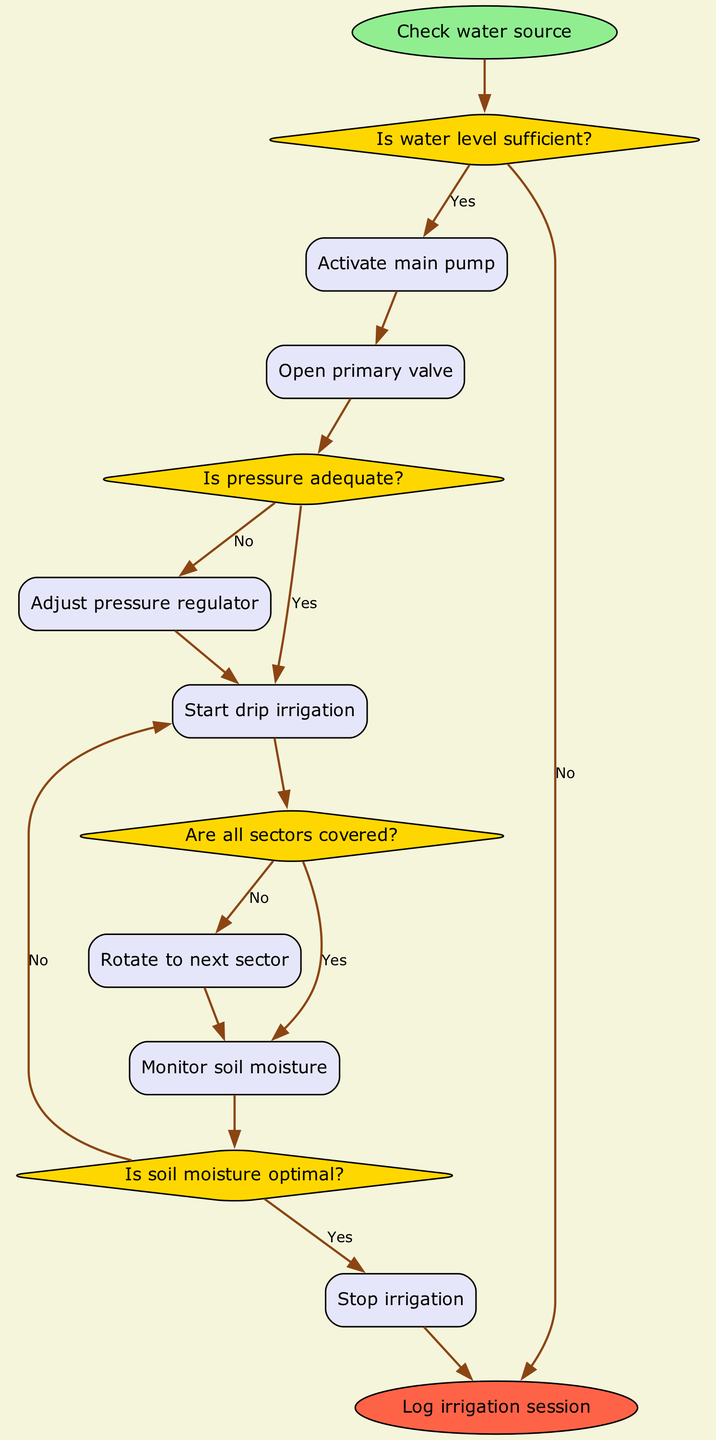What is the starting action in the irrigation system? The first action in the irrigation system is to check the water source, as indicated at the beginning of the flowchart.
Answer: Check water source What happens if the water level is insufficient? If the water level is insufficient, the flowchart indicates that the process ends without activating the main pump and stops the irrigation actions.
Answer: End How many decision points are there in the irrigation operation? The flowchart illustrates four decision points where conditions are checked, specifically regarding water level, pressure, sector coverage, and soil moisture.
Answer: Four What is the action taken if the pressure is inadequate? If the pressure is inadequate, the next action taken is to adjust the pressure regulator, as shown proceeding from the corresponding decision node.
Answer: Adjust pressure regulator What action is taken once all sectors are covered? The flowchart indicates that once all sectors are covered, the next step is to monitor soil moisture, moving onward from that decision.
Answer: Monitor soil moisture How do you know when to stop the irrigation process? The irrigation process is stopped when the soil moisture is found to be optimal. This is indicated by the decision point that checks soil moisture levels before stopping.
Answer: Stop irrigation What leads to the action of starting drip irrigation? The flowchart shows that starting drip irrigation occurs only if the pressure is adequate, establishing a direct correlation between pressure sufficiency and this action.
Answer: Start drip irrigation Which action directly leads to logging the irrigation session? The action of stopping irrigation leads directly to logging the irrigation session, marking the conclusion of the operation in the flowchart.
Answer: Log irrigation session What is the first action taken after activating the main pump? After activating the main pump, the subsequent action is to open the primary valve, which is clearly outlined in the flow diagram as part of the irrigation process.
Answer: Open primary valve 